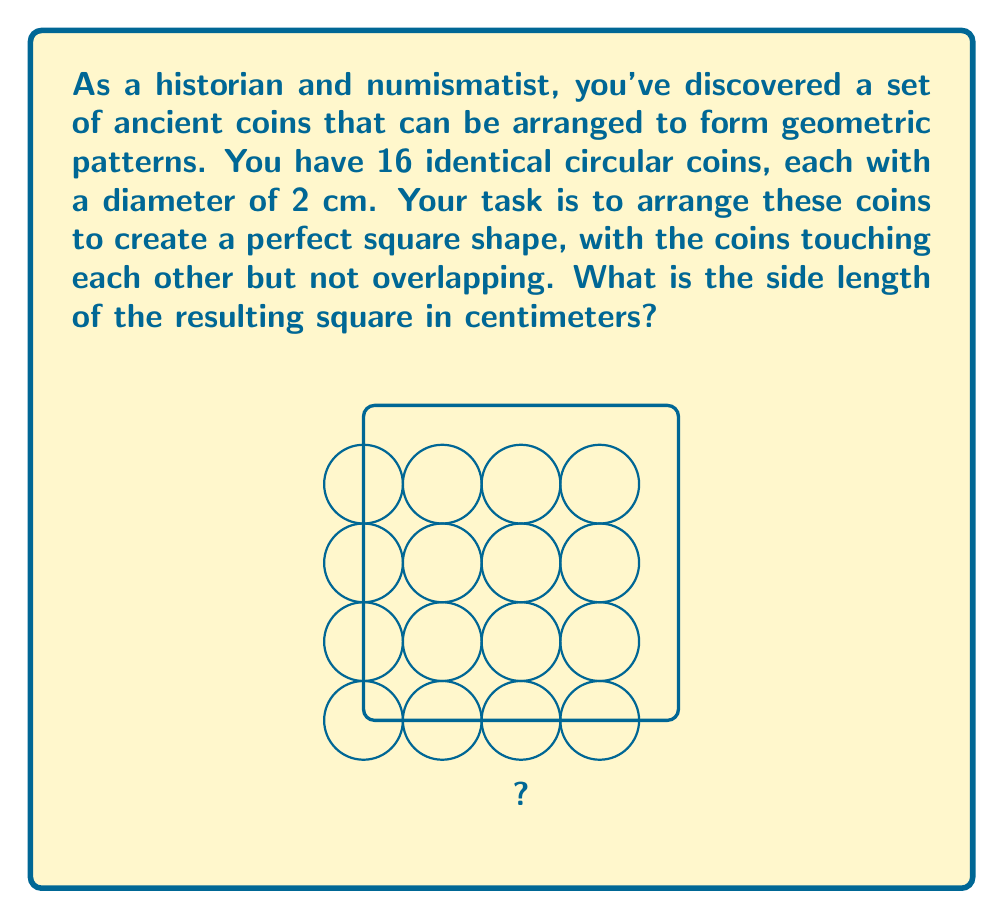Can you solve this math problem? Let's approach this step-by-step:

1) We know that we have 16 coins, which can be arranged in a 4x4 grid to form a square.

2) Each coin has a diameter of 2 cm. This means that the center-to-center distance between adjacent coins in the arrangement will be 2 cm.

3) In a 4x4 grid, there are 3 gaps between coins both horizontally and vertically.

4) The side length of the square can be calculated as follows:
   
   $$\text{Side length} = (\text{Number of coins per side} \times \text{Diameter}) - (\text{Number of gaps} \times \text{Diameter})$$

5) Substituting the values:
   
   $$\text{Side length} = (4 \times 2 \text{ cm}) - (1 \times 2 \text{ cm})$$

6) Simplifying:
   
   $$\text{Side length} = 8 \text{ cm} - 2 \text{ cm} = 6 \text{ cm}$$

Therefore, the side length of the resulting square is 6 cm.
Answer: 6 cm 